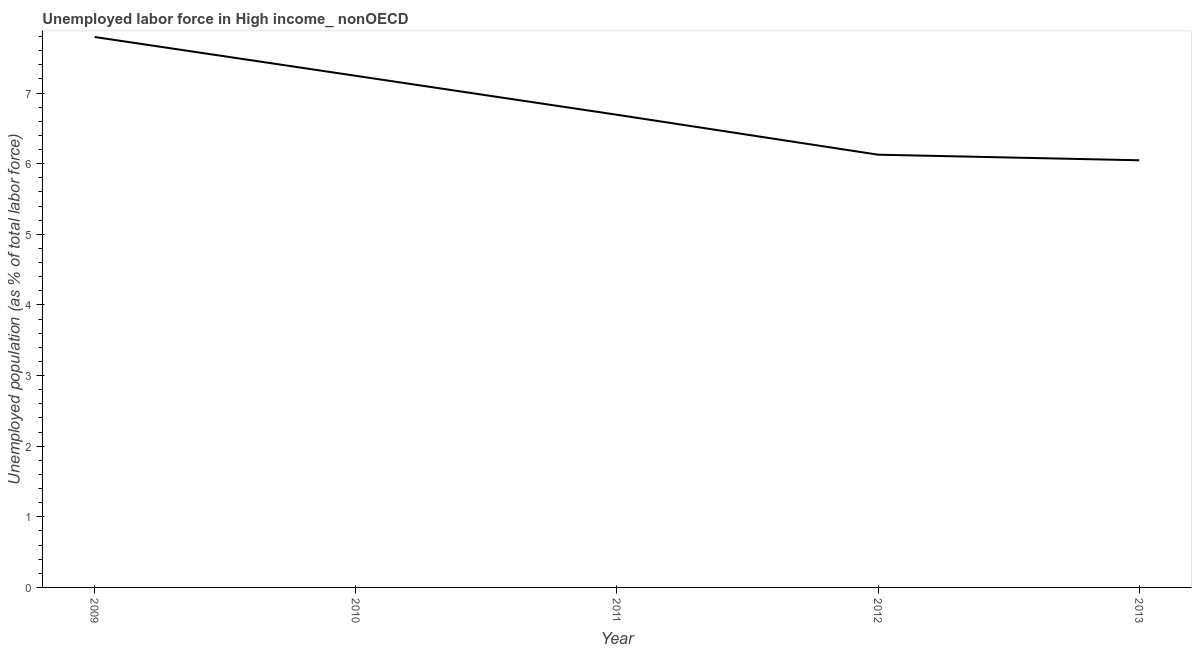What is the total unemployed population in 2010?
Provide a short and direct response. 7.24. Across all years, what is the maximum total unemployed population?
Ensure brevity in your answer.  7.79. Across all years, what is the minimum total unemployed population?
Provide a succinct answer. 6.05. What is the sum of the total unemployed population?
Provide a short and direct response. 33.9. What is the difference between the total unemployed population in 2011 and 2012?
Provide a short and direct response. 0.57. What is the average total unemployed population per year?
Provide a short and direct response. 6.78. What is the median total unemployed population?
Offer a very short reply. 6.69. What is the ratio of the total unemployed population in 2010 to that in 2012?
Your answer should be compact. 1.18. Is the total unemployed population in 2009 less than that in 2013?
Provide a succinct answer. No. Is the difference between the total unemployed population in 2009 and 2013 greater than the difference between any two years?
Provide a succinct answer. Yes. What is the difference between the highest and the second highest total unemployed population?
Your answer should be very brief. 0.55. What is the difference between the highest and the lowest total unemployed population?
Your answer should be very brief. 1.75. Does the total unemployed population monotonically increase over the years?
Make the answer very short. No. How many years are there in the graph?
Give a very brief answer. 5. What is the difference between two consecutive major ticks on the Y-axis?
Offer a very short reply. 1. What is the title of the graph?
Your answer should be very brief. Unemployed labor force in High income_ nonOECD. What is the label or title of the X-axis?
Your answer should be compact. Year. What is the label or title of the Y-axis?
Your response must be concise. Unemployed population (as % of total labor force). What is the Unemployed population (as % of total labor force) in 2009?
Give a very brief answer. 7.79. What is the Unemployed population (as % of total labor force) in 2010?
Offer a very short reply. 7.24. What is the Unemployed population (as % of total labor force) in 2011?
Your answer should be very brief. 6.69. What is the Unemployed population (as % of total labor force) in 2012?
Provide a short and direct response. 6.13. What is the Unemployed population (as % of total labor force) of 2013?
Make the answer very short. 6.05. What is the difference between the Unemployed population (as % of total labor force) in 2009 and 2010?
Your answer should be compact. 0.55. What is the difference between the Unemployed population (as % of total labor force) in 2009 and 2011?
Ensure brevity in your answer.  1.1. What is the difference between the Unemployed population (as % of total labor force) in 2009 and 2012?
Ensure brevity in your answer.  1.67. What is the difference between the Unemployed population (as % of total labor force) in 2009 and 2013?
Your response must be concise. 1.75. What is the difference between the Unemployed population (as % of total labor force) in 2010 and 2011?
Make the answer very short. 0.55. What is the difference between the Unemployed population (as % of total labor force) in 2010 and 2012?
Your response must be concise. 1.12. What is the difference between the Unemployed population (as % of total labor force) in 2010 and 2013?
Your answer should be very brief. 1.2. What is the difference between the Unemployed population (as % of total labor force) in 2011 and 2012?
Provide a succinct answer. 0.57. What is the difference between the Unemployed population (as % of total labor force) in 2011 and 2013?
Keep it short and to the point. 0.64. What is the difference between the Unemployed population (as % of total labor force) in 2012 and 2013?
Your answer should be very brief. 0.08. What is the ratio of the Unemployed population (as % of total labor force) in 2009 to that in 2010?
Keep it short and to the point. 1.08. What is the ratio of the Unemployed population (as % of total labor force) in 2009 to that in 2011?
Provide a succinct answer. 1.17. What is the ratio of the Unemployed population (as % of total labor force) in 2009 to that in 2012?
Offer a terse response. 1.27. What is the ratio of the Unemployed population (as % of total labor force) in 2009 to that in 2013?
Provide a short and direct response. 1.29. What is the ratio of the Unemployed population (as % of total labor force) in 2010 to that in 2011?
Your answer should be compact. 1.08. What is the ratio of the Unemployed population (as % of total labor force) in 2010 to that in 2012?
Your answer should be compact. 1.18. What is the ratio of the Unemployed population (as % of total labor force) in 2010 to that in 2013?
Offer a terse response. 1.2. What is the ratio of the Unemployed population (as % of total labor force) in 2011 to that in 2012?
Offer a terse response. 1.09. What is the ratio of the Unemployed population (as % of total labor force) in 2011 to that in 2013?
Make the answer very short. 1.11. 